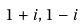<formula> <loc_0><loc_0><loc_500><loc_500>1 + i , 1 - i</formula> 